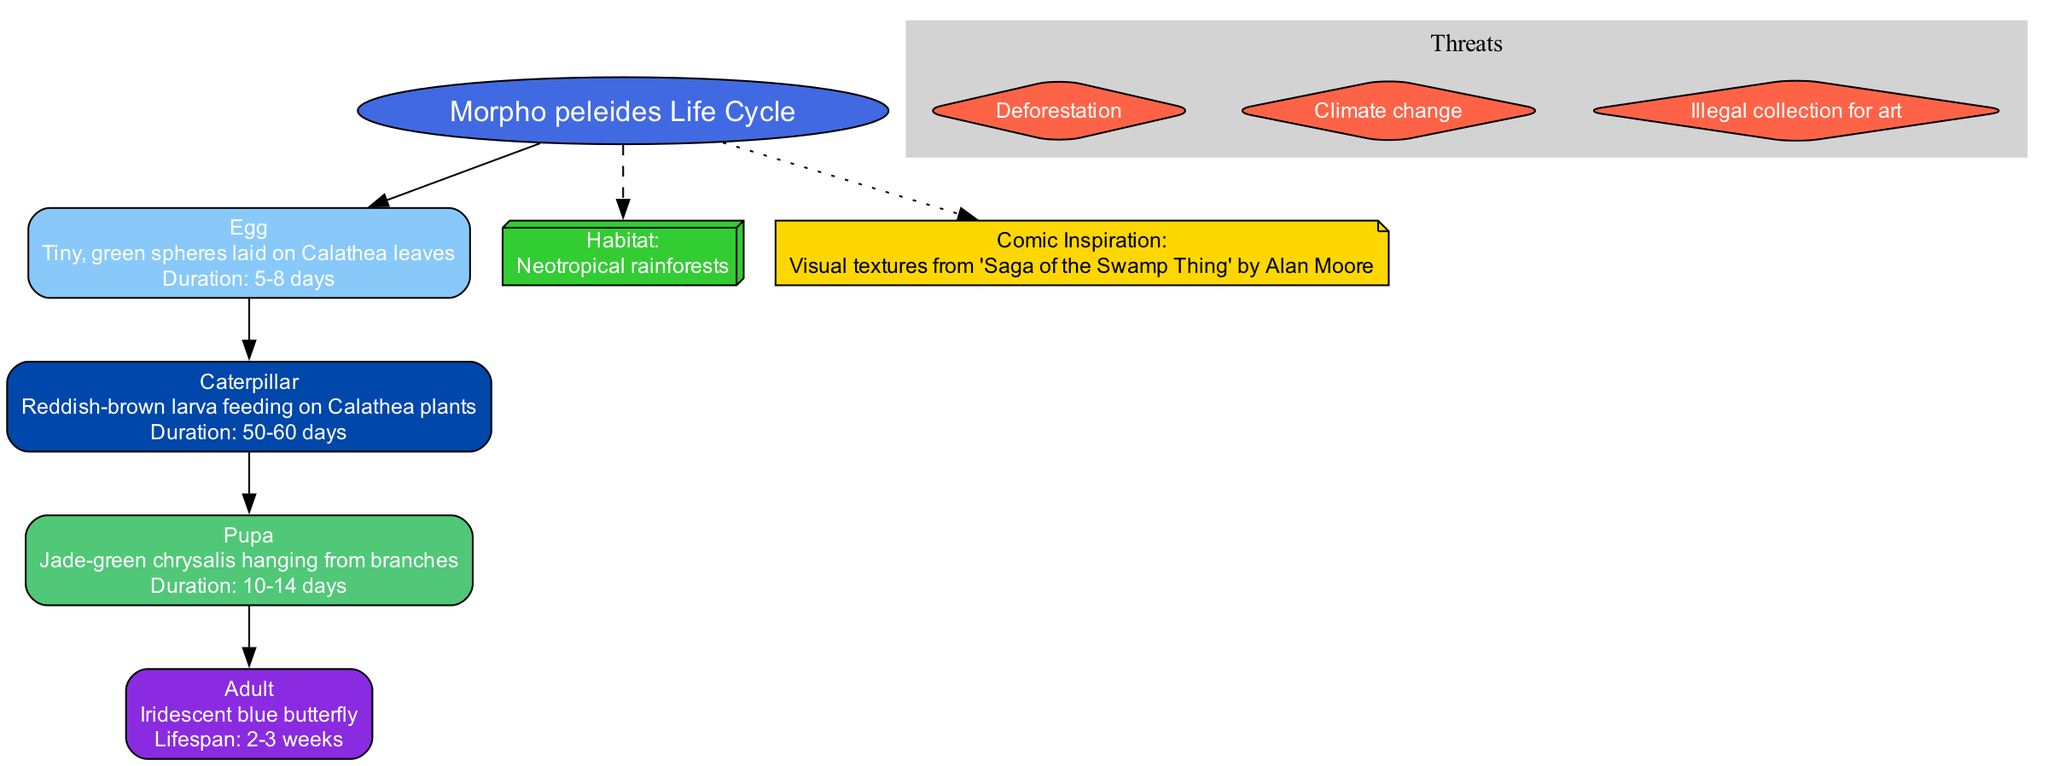What is the first stage of the Morpho peleides life cycle? The first stage is labeled as "Egg" in the diagram, which is found directly connected to the central topic.
Answer: Egg How long does the caterpillar stage last? The caterpillar stage's duration is provided in the description of the "Caterpillar" node, which is between 50 to 60 days.
Answer: 50-60 days What habitat does the Morpho peleides butterfly reside in? The habitat is indicated in a separate box connected to the central topic, labeled as "Habitat," which states "Neotropical rainforests."
Answer: Neotropical rainforests What are the threats listed for this butterfly species? The threats are represented in a clustered section labeled "Threats," where a diamond shape indicates each specific threat. These include "Deforestation," "Climate change," and "Illegal collection for art."
Answer: Deforestation, Climate change, Illegal collection for art What is the lifespan of the adult Morpho peleides butterfly? The lifespan can be found under the "Adult" stage label, which specifies that it lasts between 2 to 3 weeks.
Answer: 2-3 weeks Which stage has a duration of 10-14 days? The duration of 10-14 days is specified under the "Pupa" stage in the diagram, as part of its description.
Answer: Pupa How does the egg stage connect to the caterpillar stage? The connection is shown by a directed edge from the "Egg" node to the "Caterpillar" node, indicating that the caterpillar comes after the egg.
Answer: Egg to Caterpillar Which comic series inspired the visual textures used in this diagram? The comic inspiration is noted in a separate node connected to the central topic, stating "Visual textures from 'Saga of the Swamp Thing' by Alan Moore."
Answer: Saga of the Swamp Thing What color represents the Pupa stage in the diagram? The "Pupa" stage is filled with a color from the defined palette, specifically the jade-green color, which can be deduced visually from the diagram structure.
Answer: Jade-green 